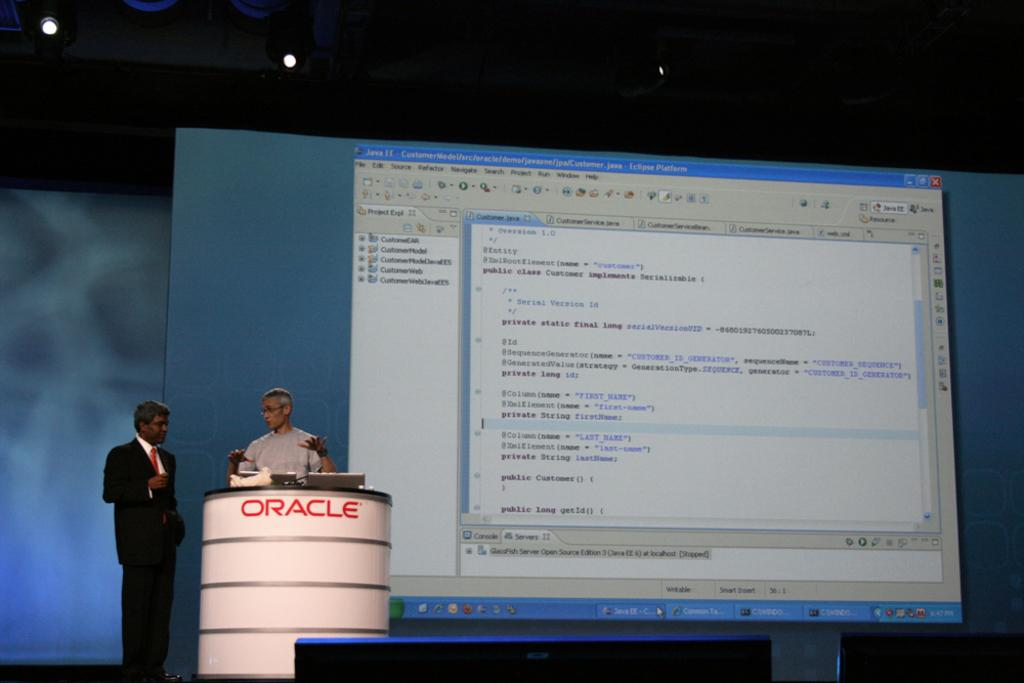<image>
Provide a brief description of the given image. A computer screen projected onto a board with Java customer code written on the top left. 